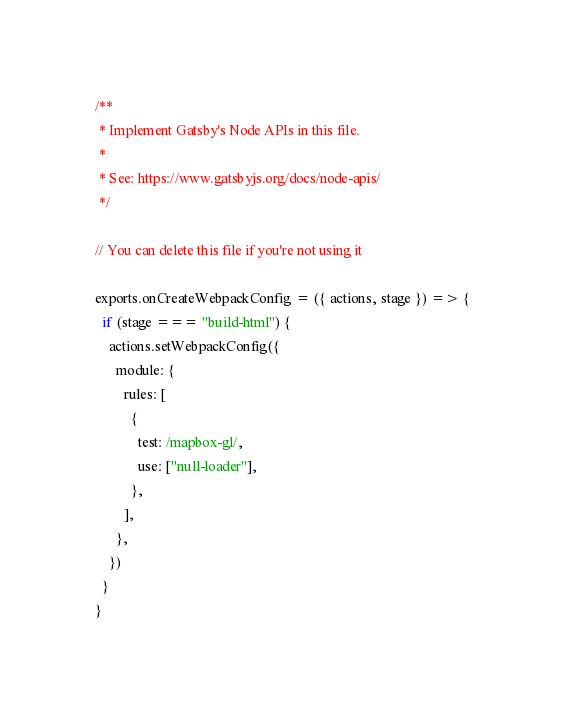Convert code to text. <code><loc_0><loc_0><loc_500><loc_500><_JavaScript_>/**
 * Implement Gatsby's Node APIs in this file.
 *
 * See: https://www.gatsbyjs.org/docs/node-apis/
 */

// You can delete this file if you're not using it

exports.onCreateWebpackConfig = ({ actions, stage }) => {
  if (stage === "build-html") {
    actions.setWebpackConfig({
      module: {
        rules: [
          {
            test: /mapbox-gl/,
            use: ["null-loader"],
          },
        ],
      },
    })
  }
}</code> 